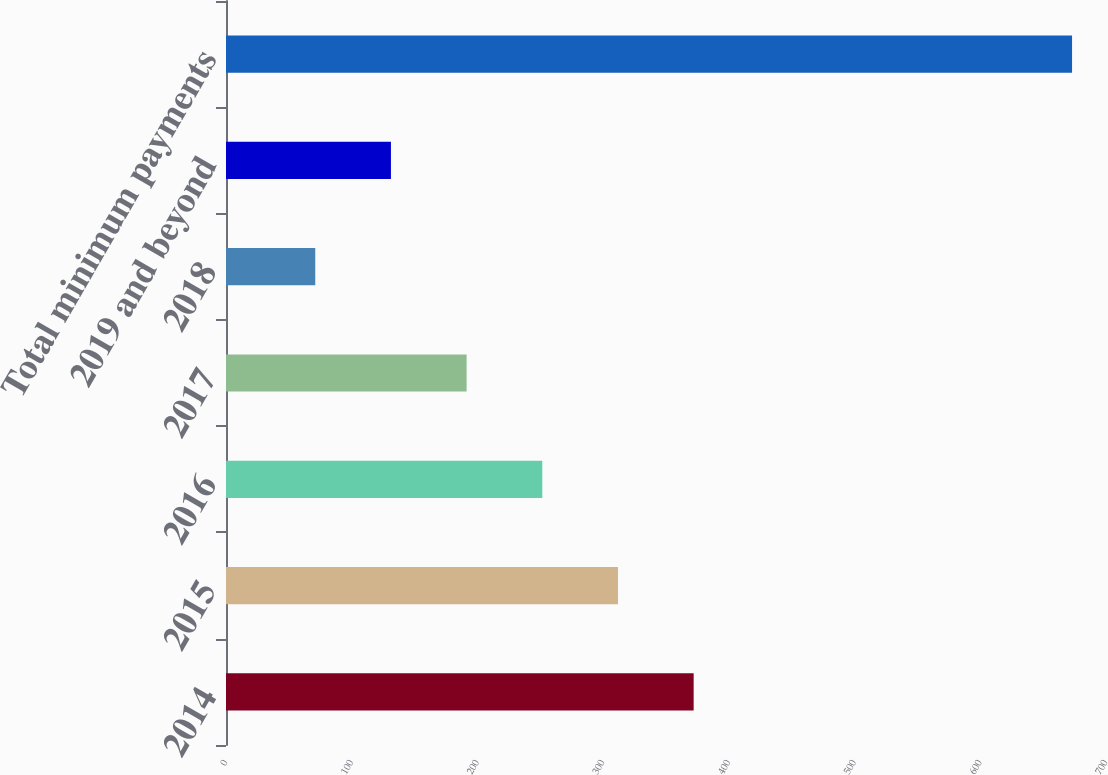Convert chart. <chart><loc_0><loc_0><loc_500><loc_500><bar_chart><fcel>2014<fcel>2015<fcel>2016<fcel>2017<fcel>2018<fcel>2019 and beyond<fcel>Total minimum payments<nl><fcel>372<fcel>311.8<fcel>251.6<fcel>191.4<fcel>71<fcel>131.2<fcel>673<nl></chart> 